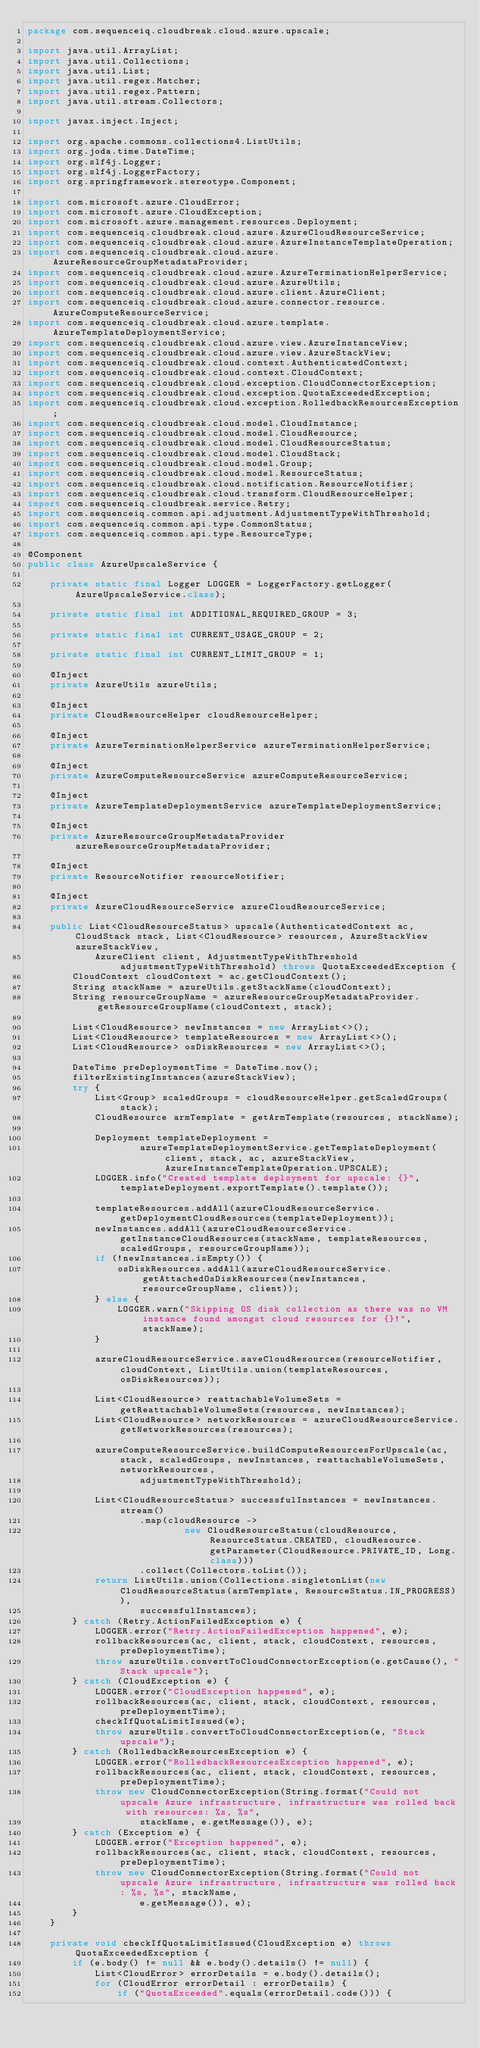Convert code to text. <code><loc_0><loc_0><loc_500><loc_500><_Java_>package com.sequenceiq.cloudbreak.cloud.azure.upscale;

import java.util.ArrayList;
import java.util.Collections;
import java.util.List;
import java.util.regex.Matcher;
import java.util.regex.Pattern;
import java.util.stream.Collectors;

import javax.inject.Inject;

import org.apache.commons.collections4.ListUtils;
import org.joda.time.DateTime;
import org.slf4j.Logger;
import org.slf4j.LoggerFactory;
import org.springframework.stereotype.Component;

import com.microsoft.azure.CloudError;
import com.microsoft.azure.CloudException;
import com.microsoft.azure.management.resources.Deployment;
import com.sequenceiq.cloudbreak.cloud.azure.AzureCloudResourceService;
import com.sequenceiq.cloudbreak.cloud.azure.AzureInstanceTemplateOperation;
import com.sequenceiq.cloudbreak.cloud.azure.AzureResourceGroupMetadataProvider;
import com.sequenceiq.cloudbreak.cloud.azure.AzureTerminationHelperService;
import com.sequenceiq.cloudbreak.cloud.azure.AzureUtils;
import com.sequenceiq.cloudbreak.cloud.azure.client.AzureClient;
import com.sequenceiq.cloudbreak.cloud.azure.connector.resource.AzureComputeResourceService;
import com.sequenceiq.cloudbreak.cloud.azure.template.AzureTemplateDeploymentService;
import com.sequenceiq.cloudbreak.cloud.azure.view.AzureInstanceView;
import com.sequenceiq.cloudbreak.cloud.azure.view.AzureStackView;
import com.sequenceiq.cloudbreak.cloud.context.AuthenticatedContext;
import com.sequenceiq.cloudbreak.cloud.context.CloudContext;
import com.sequenceiq.cloudbreak.cloud.exception.CloudConnectorException;
import com.sequenceiq.cloudbreak.cloud.exception.QuotaExceededException;
import com.sequenceiq.cloudbreak.cloud.exception.RolledbackResourcesException;
import com.sequenceiq.cloudbreak.cloud.model.CloudInstance;
import com.sequenceiq.cloudbreak.cloud.model.CloudResource;
import com.sequenceiq.cloudbreak.cloud.model.CloudResourceStatus;
import com.sequenceiq.cloudbreak.cloud.model.CloudStack;
import com.sequenceiq.cloudbreak.cloud.model.Group;
import com.sequenceiq.cloudbreak.cloud.model.ResourceStatus;
import com.sequenceiq.cloudbreak.cloud.notification.ResourceNotifier;
import com.sequenceiq.cloudbreak.cloud.transform.CloudResourceHelper;
import com.sequenceiq.cloudbreak.service.Retry;
import com.sequenceiq.common.api.adjustment.AdjustmentTypeWithThreshold;
import com.sequenceiq.common.api.type.CommonStatus;
import com.sequenceiq.common.api.type.ResourceType;

@Component
public class AzureUpscaleService {

    private static final Logger LOGGER = LoggerFactory.getLogger(AzureUpscaleService.class);

    private static final int ADDITIONAL_REQUIRED_GROUP = 3;

    private static final int CURRENT_USAGE_GROUP = 2;

    private static final int CURRENT_LIMIT_GROUP = 1;

    @Inject
    private AzureUtils azureUtils;

    @Inject
    private CloudResourceHelper cloudResourceHelper;

    @Inject
    private AzureTerminationHelperService azureTerminationHelperService;

    @Inject
    private AzureComputeResourceService azureComputeResourceService;

    @Inject
    private AzureTemplateDeploymentService azureTemplateDeploymentService;

    @Inject
    private AzureResourceGroupMetadataProvider azureResourceGroupMetadataProvider;

    @Inject
    private ResourceNotifier resourceNotifier;

    @Inject
    private AzureCloudResourceService azureCloudResourceService;

    public List<CloudResourceStatus> upscale(AuthenticatedContext ac, CloudStack stack, List<CloudResource> resources, AzureStackView azureStackView,
            AzureClient client, AdjustmentTypeWithThreshold adjustmentTypeWithThreshold) throws QuotaExceededException {
        CloudContext cloudContext = ac.getCloudContext();
        String stackName = azureUtils.getStackName(cloudContext);
        String resourceGroupName = azureResourceGroupMetadataProvider.getResourceGroupName(cloudContext, stack);

        List<CloudResource> newInstances = new ArrayList<>();
        List<CloudResource> templateResources = new ArrayList<>();
        List<CloudResource> osDiskResources = new ArrayList<>();

        DateTime preDeploymentTime = DateTime.now();
        filterExistingInstances(azureStackView);
        try {
            List<Group> scaledGroups = cloudResourceHelper.getScaledGroups(stack);
            CloudResource armTemplate = getArmTemplate(resources, stackName);

            Deployment templateDeployment =
                    azureTemplateDeploymentService.getTemplateDeployment(client, stack, ac, azureStackView, AzureInstanceTemplateOperation.UPSCALE);
            LOGGER.info("Created template deployment for upscale: {}", templateDeployment.exportTemplate().template());

            templateResources.addAll(azureCloudResourceService.getDeploymentCloudResources(templateDeployment));
            newInstances.addAll(azureCloudResourceService.getInstanceCloudResources(stackName, templateResources, scaledGroups, resourceGroupName));
            if (!newInstances.isEmpty()) {
                osDiskResources.addAll(azureCloudResourceService.getAttachedOsDiskResources(newInstances, resourceGroupName, client));
            } else {
                LOGGER.warn("Skipping OS disk collection as there was no VM instance found amongst cloud resources for {}!", stackName);
            }

            azureCloudResourceService.saveCloudResources(resourceNotifier, cloudContext, ListUtils.union(templateResources, osDiskResources));

            List<CloudResource> reattachableVolumeSets = getReattachableVolumeSets(resources, newInstances);
            List<CloudResource> networkResources = azureCloudResourceService.getNetworkResources(resources);

            azureComputeResourceService.buildComputeResourcesForUpscale(ac, stack, scaledGroups, newInstances, reattachableVolumeSets, networkResources,
                    adjustmentTypeWithThreshold);

            List<CloudResourceStatus> successfulInstances = newInstances.stream()
                    .map(cloudResource ->
                            new CloudResourceStatus(cloudResource, ResourceStatus.CREATED, cloudResource.getParameter(CloudResource.PRIVATE_ID, Long.class)))
                    .collect(Collectors.toList());
            return ListUtils.union(Collections.singletonList(new CloudResourceStatus(armTemplate, ResourceStatus.IN_PROGRESS)),
                    successfulInstances);
        } catch (Retry.ActionFailedException e) {
            LOGGER.error("Retry.ActionFailedException happened", e);
            rollbackResources(ac, client, stack, cloudContext, resources, preDeploymentTime);
            throw azureUtils.convertToCloudConnectorException(e.getCause(), "Stack upscale");
        } catch (CloudException e) {
            LOGGER.error("CloudException happened", e);
            rollbackResources(ac, client, stack, cloudContext, resources, preDeploymentTime);
            checkIfQuotaLimitIssued(e);
            throw azureUtils.convertToCloudConnectorException(e, "Stack upscale");
        } catch (RolledbackResourcesException e) {
            LOGGER.error("RolledbackResourcesException happened", e);
            rollbackResources(ac, client, stack, cloudContext, resources, preDeploymentTime);
            throw new CloudConnectorException(String.format("Could not upscale Azure infrastructure, infrastructure was rolled back with resources: %s, %s",
                    stackName, e.getMessage()), e);
        } catch (Exception e) {
            LOGGER.error("Exception happened", e);
            rollbackResources(ac, client, stack, cloudContext, resources, preDeploymentTime);
            throw new CloudConnectorException(String.format("Could not upscale Azure infrastructure, infrastructure was rolled back: %s, %s", stackName,
                    e.getMessage()), e);
        }
    }

    private void checkIfQuotaLimitIssued(CloudException e) throws QuotaExceededException {
        if (e.body() != null && e.body().details() != null) {
            List<CloudError> errorDetails = e.body().details();
            for (CloudError errorDetail : errorDetails) {
                if ("QuotaExceeded".equals(errorDetail.code())) {</code> 